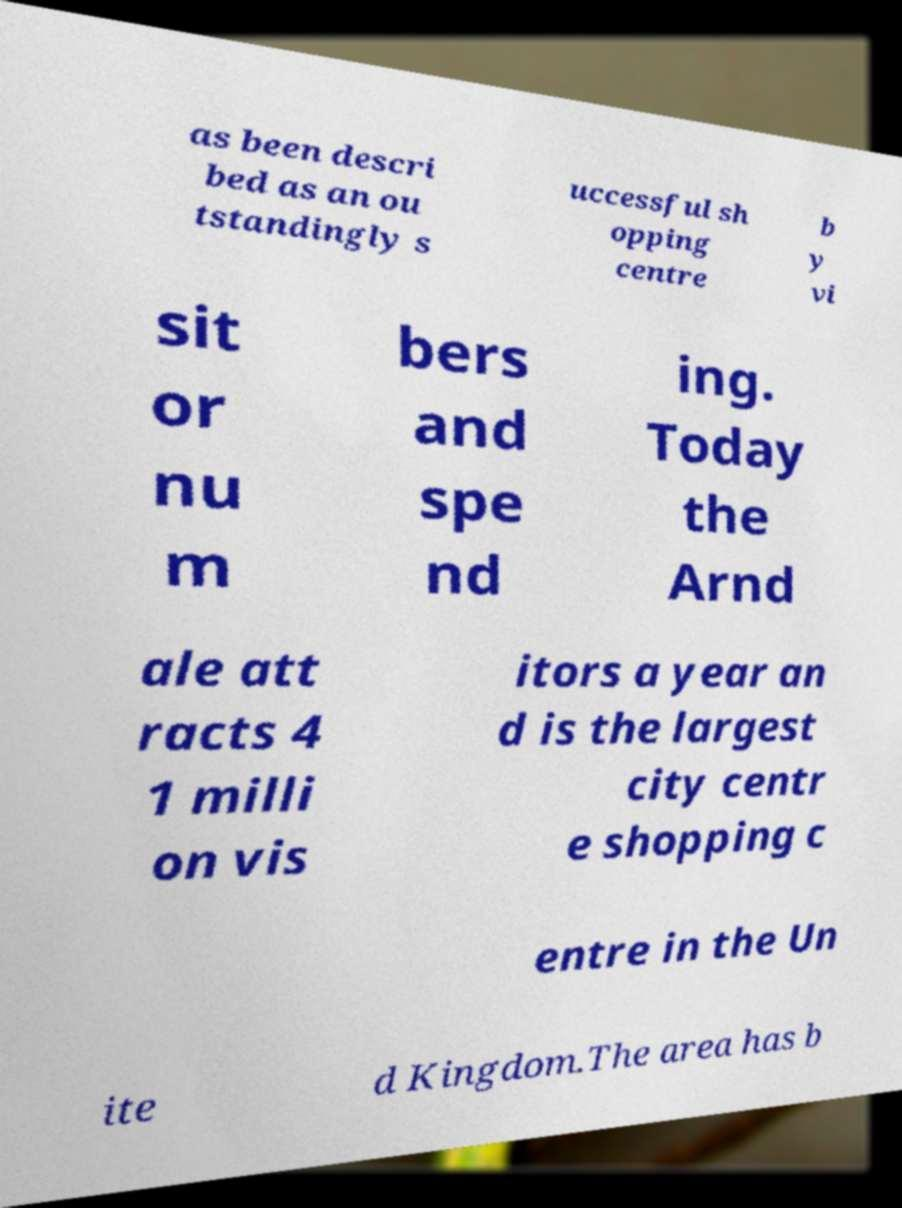Could you assist in decoding the text presented in this image and type it out clearly? as been descri bed as an ou tstandingly s uccessful sh opping centre b y vi sit or nu m bers and spe nd ing. Today the Arnd ale att racts 4 1 milli on vis itors a year an d is the largest city centr e shopping c entre in the Un ite d Kingdom.The area has b 